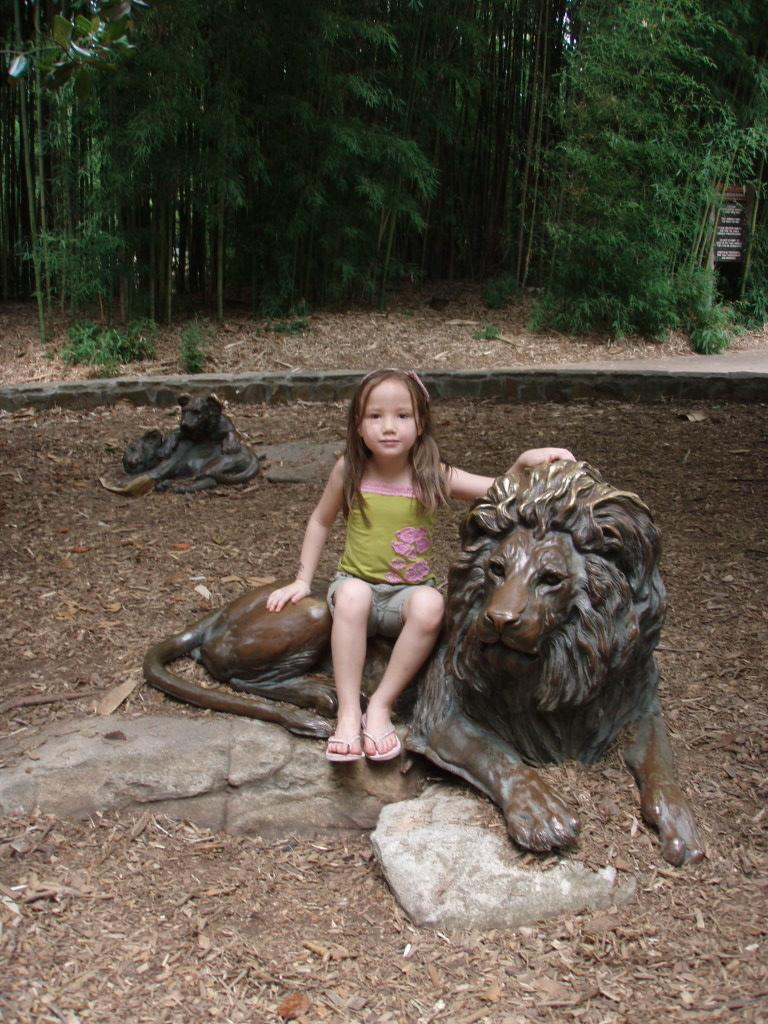What type of natural elements can be seen at the top of the image? There are trees at the top of the image. What type of objects are located in the middle of the image? There are statues of animals in the middle of the image. What is the kid doing in the image? A kid is sitting on the statues. What type of hate can be seen in the image? There is no hate present in the image; it features trees, statues of animals, and a kid sitting on the statues. What is the silver representative in the image? There is no silver representative present in the image. 